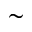<formula> <loc_0><loc_0><loc_500><loc_500>\sim</formula> 